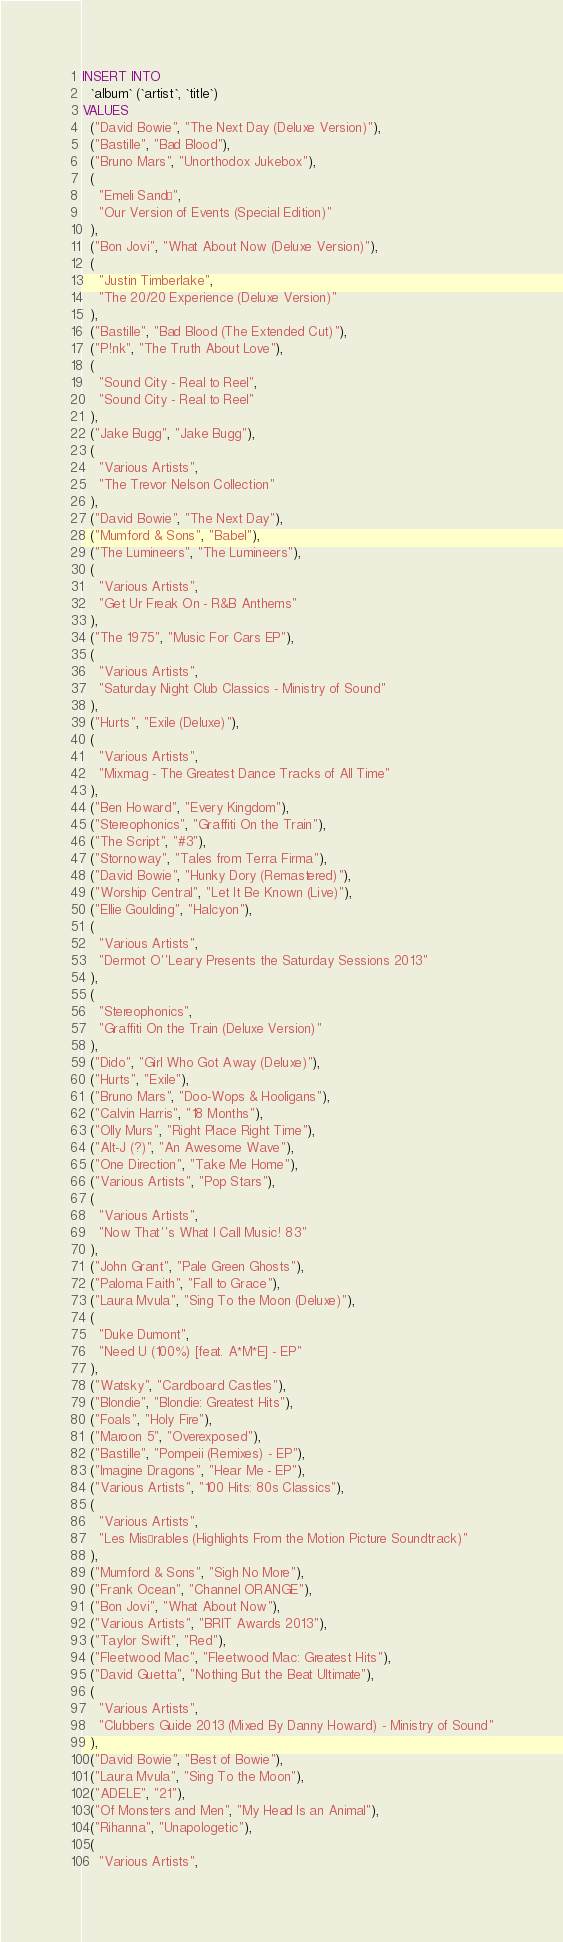Convert code to text. <code><loc_0><loc_0><loc_500><loc_500><_SQL_>INSERT INTO
  `album` (`artist`, `title`)
VALUES
  ("David Bowie", "The Next Day (Deluxe Version)"),
  ("Bastille", "Bad Blood"),
  ("Bruno Mars", "Unorthodox Jukebox"),
  (
    "Emeli Sandé",
    "Our Version of Events (Special Edition)"
  ),
  ("Bon Jovi", "What About Now (Deluxe Version)"),
  (
    "Justin Timberlake",
    "The 20/20 Experience (Deluxe Version)"
  ),
  ("Bastille", "Bad Blood (The Extended Cut)"),
  ("P!nk", "The Truth About Love"),
  (
    "Sound City - Real to Reel",
    "Sound City - Real to Reel"
  ),
  ("Jake Bugg", "Jake Bugg"),
  (
    "Various Artists",
    "The Trevor Nelson Collection"
  ),
  ("David Bowie", "The Next Day"),
  ("Mumford & Sons", "Babel"),
  ("The Lumineers", "The Lumineers"),
  (
    "Various Artists",
    "Get Ur Freak On - R&B Anthems"
  ),
  ("The 1975", "Music For Cars EP"),
  (
    "Various Artists",
    "Saturday Night Club Classics - Ministry of Sound"
  ),
  ("Hurts", "Exile (Deluxe)"),
  (
    "Various Artists",
    "Mixmag - The Greatest Dance Tracks of All Time"
  ),
  ("Ben Howard", "Every Kingdom"),
  ("Stereophonics", "Graffiti On the Train"),
  ("The Script", "#3"),
  ("Stornoway", "Tales from Terra Firma"),
  ("David Bowie", "Hunky Dory (Remastered)"),
  ("Worship Central", "Let It Be Known (Live)"),
  ("Ellie Goulding", "Halcyon"),
  (
    "Various Artists",
    "Dermot O''Leary Presents the Saturday Sessions 2013"
  ),
  (
    "Stereophonics",
    "Graffiti On the Train (Deluxe Version)"
  ),
  ("Dido", "Girl Who Got Away (Deluxe)"),
  ("Hurts", "Exile"),
  ("Bruno Mars", "Doo-Wops & Hooligans"),
  ("Calvin Harris", "18 Months"),
  ("Olly Murs", "Right Place Right Time"),
  ("Alt-J (?)", "An Awesome Wave"),
  ("One Direction", "Take Me Home"),
  ("Various Artists", "Pop Stars"),
  (
    "Various Artists",
    "Now That''s What I Call Music! 83"
  ),
  ("John Grant", "Pale Green Ghosts"),
  ("Paloma Faith", "Fall to Grace"),
  ("Laura Mvula", "Sing To the Moon (Deluxe)"),
  (
    "Duke Dumont",
    "Need U (100%) [feat. A*M*E] - EP"
  ),
  ("Watsky", "Cardboard Castles"),
  ("Blondie", "Blondie: Greatest Hits"),
  ("Foals", "Holy Fire"),
  ("Maroon 5", "Overexposed"),
  ("Bastille", "Pompeii (Remixes) - EP"),
  ("Imagine Dragons", "Hear Me - EP"),
  ("Various Artists", "100 Hits: 80s Classics"),
  (
    "Various Artists",
    "Les Misérables (Highlights From the Motion Picture Soundtrack)"
  ),
  ("Mumford & Sons", "Sigh No More"),
  ("Frank Ocean", "Channel ORANGE"),
  ("Bon Jovi", "What About Now"),
  ("Various Artists", "BRIT Awards 2013"),
  ("Taylor Swift", "Red"),
  ("Fleetwood Mac", "Fleetwood Mac: Greatest Hits"),
  ("David Guetta", "Nothing But the Beat Ultimate"),
  (
    "Various Artists",
    "Clubbers Guide 2013 (Mixed By Danny Howard) - Ministry of Sound"
  ),
  ("David Bowie", "Best of Bowie"),
  ("Laura Mvula", "Sing To the Moon"),
  ("ADELE", "21"),
  ("Of Monsters and Men", "My Head Is an Animal"),
  ("Rihanna", "Unapologetic"),
  (
    "Various Artists",</code> 